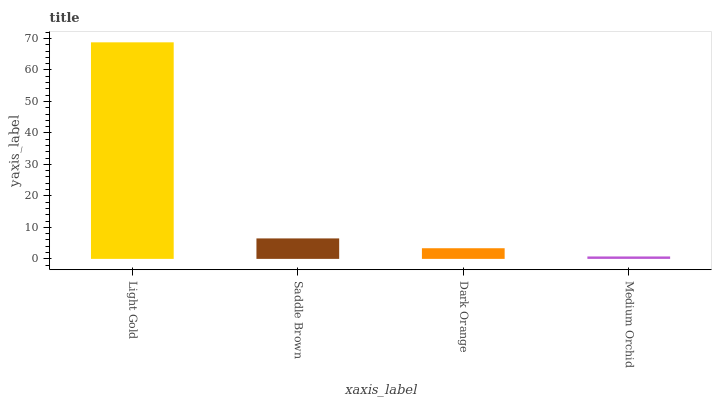Is Saddle Brown the minimum?
Answer yes or no. No. Is Saddle Brown the maximum?
Answer yes or no. No. Is Light Gold greater than Saddle Brown?
Answer yes or no. Yes. Is Saddle Brown less than Light Gold?
Answer yes or no. Yes. Is Saddle Brown greater than Light Gold?
Answer yes or no. No. Is Light Gold less than Saddle Brown?
Answer yes or no. No. Is Saddle Brown the high median?
Answer yes or no. Yes. Is Dark Orange the low median?
Answer yes or no. Yes. Is Dark Orange the high median?
Answer yes or no. No. Is Light Gold the low median?
Answer yes or no. No. 